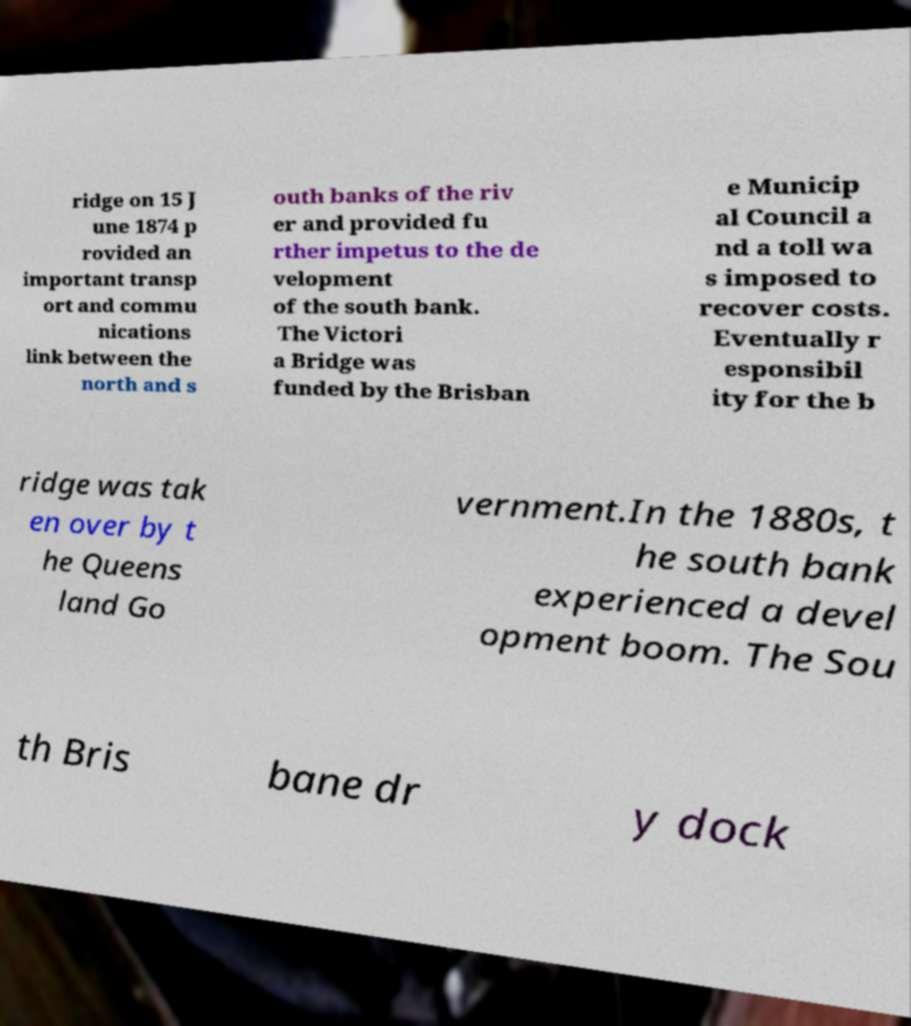What messages or text are displayed in this image? I need them in a readable, typed format. ridge on 15 J une 1874 p rovided an important transp ort and commu nications link between the north and s outh banks of the riv er and provided fu rther impetus to the de velopment of the south bank. The Victori a Bridge was funded by the Brisban e Municip al Council a nd a toll wa s imposed to recover costs. Eventually r esponsibil ity for the b ridge was tak en over by t he Queens land Go vernment.In the 1880s, t he south bank experienced a devel opment boom. The Sou th Bris bane dr y dock 